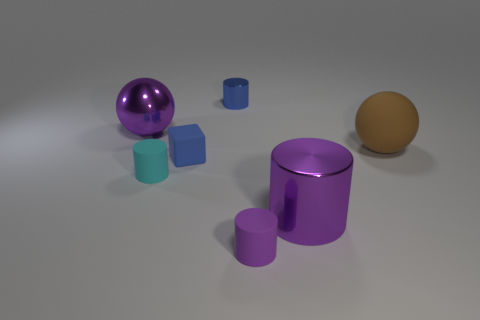Subtract all cyan cylinders. How many cylinders are left? 3 Subtract all blue shiny cylinders. How many cylinders are left? 3 Subtract all brown cylinders. Subtract all gray cubes. How many cylinders are left? 4 Add 1 big green shiny objects. How many objects exist? 8 Subtract all spheres. How many objects are left? 5 Add 4 tiny cyan shiny spheres. How many tiny cyan shiny spheres exist? 4 Subtract 0 red cylinders. How many objects are left? 7 Subtract all small cyan objects. Subtract all big purple objects. How many objects are left? 4 Add 3 purple spheres. How many purple spheres are left? 4 